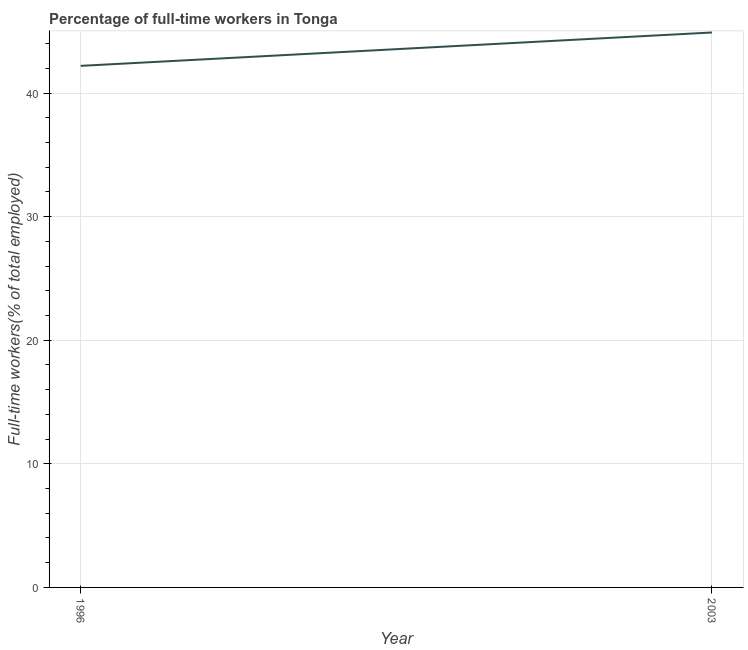What is the percentage of full-time workers in 1996?
Provide a succinct answer. 42.2. Across all years, what is the maximum percentage of full-time workers?
Make the answer very short. 44.9. Across all years, what is the minimum percentage of full-time workers?
Make the answer very short. 42.2. In which year was the percentage of full-time workers maximum?
Offer a very short reply. 2003. What is the sum of the percentage of full-time workers?
Give a very brief answer. 87.1. What is the difference between the percentage of full-time workers in 1996 and 2003?
Ensure brevity in your answer.  -2.7. What is the average percentage of full-time workers per year?
Give a very brief answer. 43.55. What is the median percentage of full-time workers?
Give a very brief answer. 43.55. In how many years, is the percentage of full-time workers greater than 14 %?
Offer a terse response. 2. Do a majority of the years between 1996 and 2003 (inclusive) have percentage of full-time workers greater than 30 %?
Ensure brevity in your answer.  Yes. What is the ratio of the percentage of full-time workers in 1996 to that in 2003?
Your response must be concise. 0.94. In how many years, is the percentage of full-time workers greater than the average percentage of full-time workers taken over all years?
Provide a succinct answer. 1. What is the difference between two consecutive major ticks on the Y-axis?
Provide a short and direct response. 10. Are the values on the major ticks of Y-axis written in scientific E-notation?
Offer a very short reply. No. Does the graph contain any zero values?
Keep it short and to the point. No. What is the title of the graph?
Provide a short and direct response. Percentage of full-time workers in Tonga. What is the label or title of the X-axis?
Offer a very short reply. Year. What is the label or title of the Y-axis?
Provide a short and direct response. Full-time workers(% of total employed). What is the Full-time workers(% of total employed) in 1996?
Make the answer very short. 42.2. What is the Full-time workers(% of total employed) of 2003?
Provide a succinct answer. 44.9. 